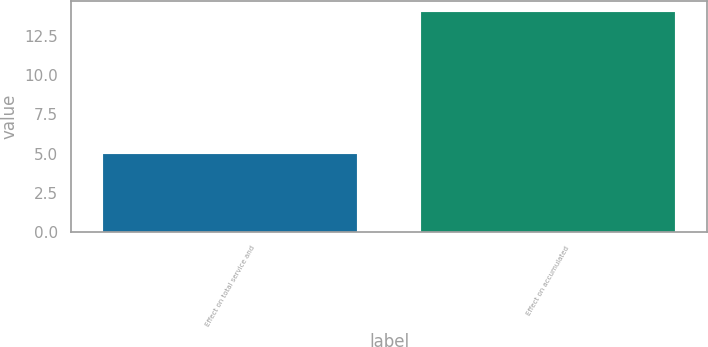<chart> <loc_0><loc_0><loc_500><loc_500><bar_chart><fcel>Effect on total service and<fcel>Effect on accumulated<nl><fcel>5<fcel>14<nl></chart> 